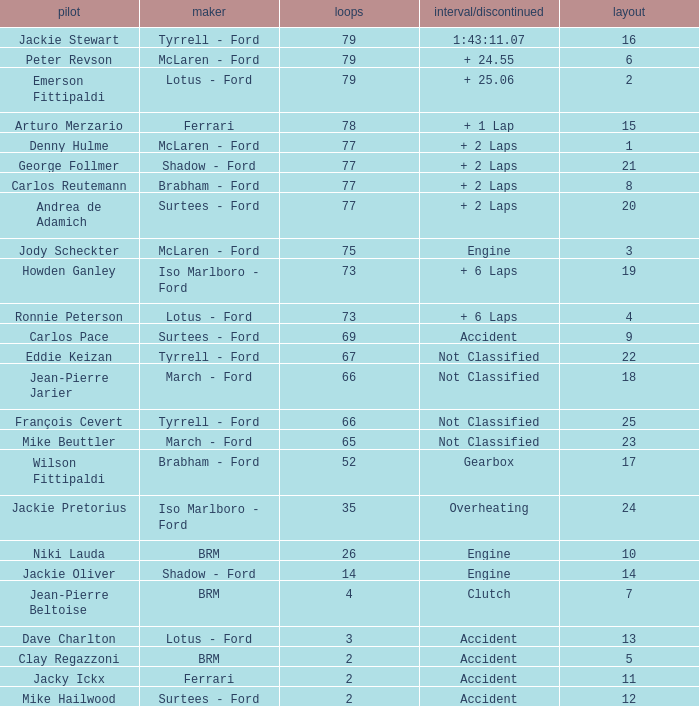What is the total grid with laps less than 2? None. 